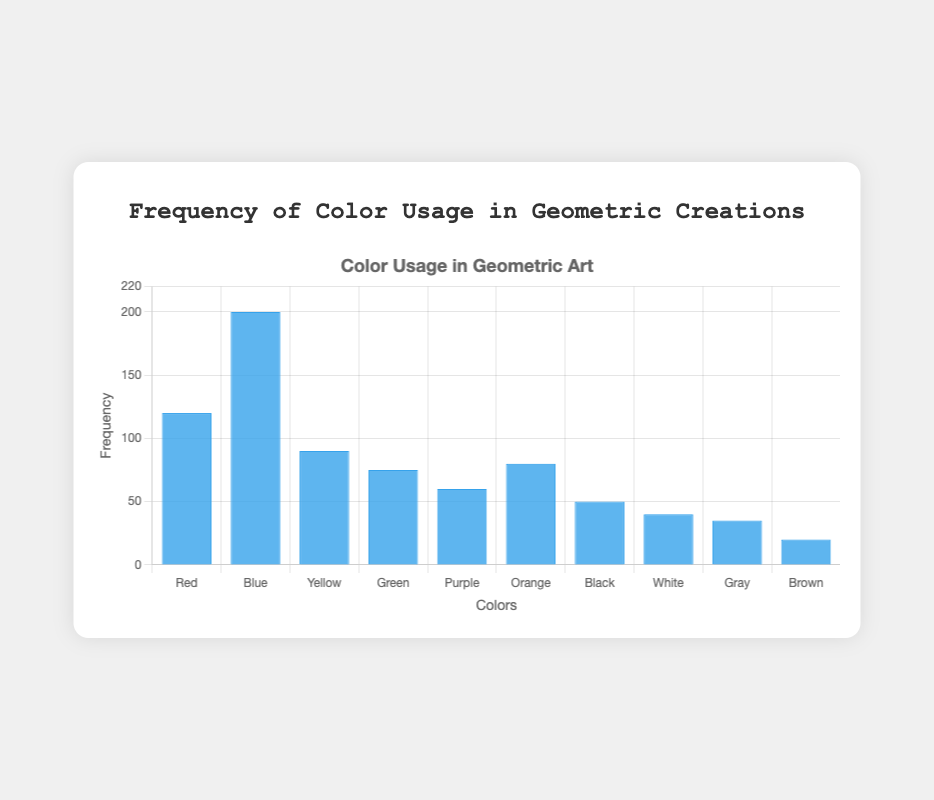Which color is used most frequently in geometric creations? The height of the Blue bar is the highest among all bars, indicating it has the maximum frequency.
Answer: Blue Which color is the least used in geometric creations? The height of the Brown bar is the shortest, indicating it has the minimum frequency.
Answer: Brown What is the sum of the frequencies of Red and Yellow? The frequency for Red is 120 and for Yellow is 90. The sum is 120 + 90 = 210.
Answer: 210 How much more frequently is Blue used compared to Green? The frequency for Blue is 200, and for Green, it is 75. The difference is 200 - 75 = 125.
Answer: 125 Which neutral color (Black, White, Gray, Brown) has the highest usage frequency? Among the neutral colors, Black has the highest frequency of 50.
Answer: Black Is the frequency of Orange higher than that of Purple? The height of the Orange bar is taller than the Purple bar, indicating a higher frequency. Orange has 80 and Purple has 60.
Answer: Yes What is the average frequency of the primary colors (Red, Blue, Yellow)? The frequencies for Red, Blue, and Yellow are 120, 200, and 90 respectively. The sum is 120 + 200 + 90 = 410. The average is 410 / 3 = 136.67.
Answer: 136.67 Which color frequencies are equal? No two bars have the same height, indicating no color frequencies are equal.
Answer: None What is the total frequency of all colors combined? The sum of all frequencies is 120 + 200 + 90 + 75 + 60 + 80 + 50 + 40 + 35 + 20 = 770.
Answer: 770 Is Gray used more frequently than White? The height of the Gray bar is shorter than the White bar, indicating less frequency. Gray has 35 and White has 40.
Answer: No 